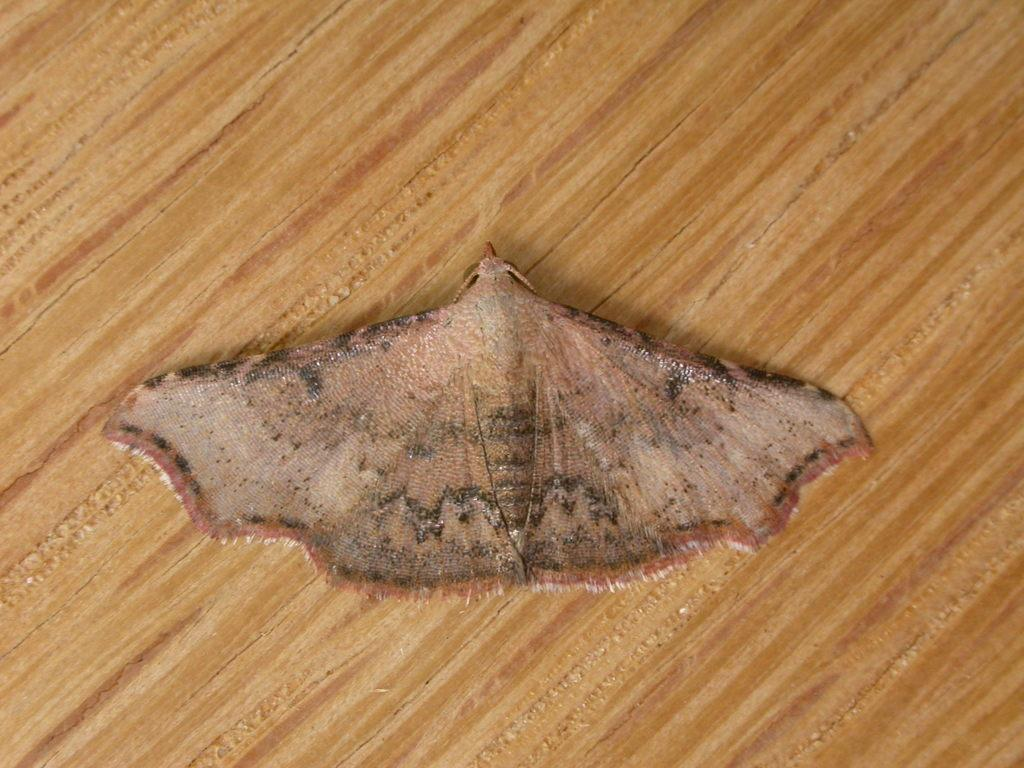What type of creature is present in the image? There is an insect in the picture. What color is the insect? The insect is brown in color. What is the insect resting on in the image? The insect is on a brown color surface. What type of weather can be seen in the image? There is no weather depicted in the image, as it only features an insect on a brown surface. What time of day is it in the image? The time of day cannot be determined from the image, as there are no clues to indicate whether it is morning, afternoon, or evening. 